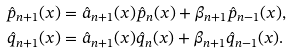Convert formula to latex. <formula><loc_0><loc_0><loc_500><loc_500>\hat { p } _ { n + 1 } ( x ) & = \hat { a } _ { n + 1 } ( x ) \hat { p } _ { n } ( x ) + \beta _ { n + 1 } \hat { p } _ { n - 1 } ( x ) , \\ \hat { q } _ { n + 1 } ( x ) & = \hat { a } _ { n + 1 } ( x ) \hat { q } _ { n } ( x ) + \beta _ { n + 1 } \hat { q } _ { n - 1 } ( x ) .</formula> 